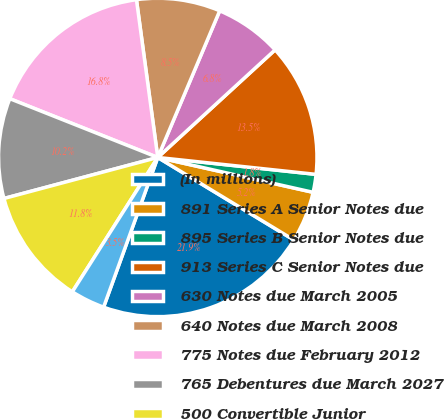Convert chart. <chart><loc_0><loc_0><loc_500><loc_500><pie_chart><fcel>(In millions)<fcel>891 Series A Senior Notes due<fcel>895 Series B Senior Notes due<fcel>913 Series C Senior Notes due<fcel>630 Notes due March 2005<fcel>640 Notes due March 2008<fcel>775 Notes due February 2012<fcel>765 Debentures due March 2027<fcel>500 Convertible Junior<fcel>ESOP related debt (see<nl><fcel>21.86%<fcel>5.16%<fcel>1.82%<fcel>13.51%<fcel>6.83%<fcel>8.5%<fcel>16.85%<fcel>10.17%<fcel>11.84%<fcel>3.49%<nl></chart> 